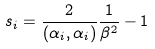Convert formula to latex. <formula><loc_0><loc_0><loc_500><loc_500>s _ { i } = \frac { 2 } { ( \alpha _ { i } , \alpha _ { i } ) } \frac { 1 } { \beta ^ { 2 } } - 1</formula> 